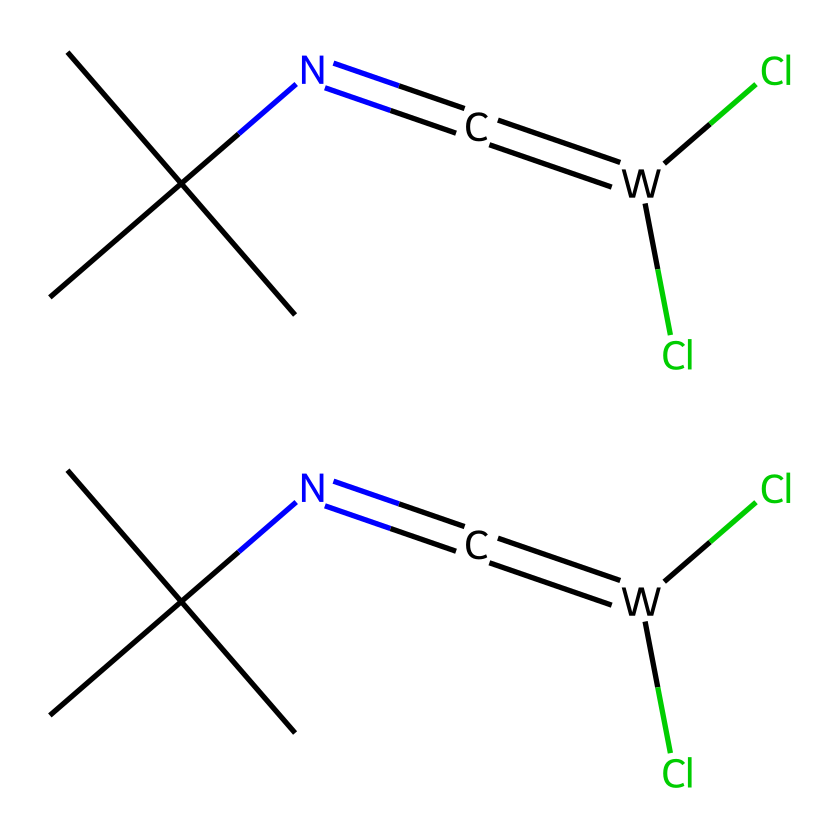What type of chemical is represented by this structure? The structure contains a divalent carbon atom bonded to two other atoms/groups, thus classifying it as a carbene. Carbenes are characterized by the presence of a carbon atom with only six electrons in its valence shell.
Answer: carbene How many chlorine atoms are present in the molecule? By examining the structure, there are two chlorine atoms indicated in the formula, which are part of the overall compound.
Answer: two What is the functional group present in this molecule? The presence of the -N=C= portion in the structure indicates that it is an imine functional group, as it consists of a nitrogen atom double-bonded to a carbon atom that is also double-bonded to another carbon atom.
Answer: imine What is the total number of carbon atoms in the chemical structure? By looking at the SMILES notation, there are six carbon atoms represented within the entire molecule.
Answer: six How many nitrogen atoms are in this chemical? The chemical structure shows there are two nitrogen atoms present, one for each carbene group in the molecule.
Answer: two What type of interactions could this carbene structure facilitate in lubricants? Carbenes can participate in various chemical interactions, notably coordination and π-stacking, which can enhance lubricant properties such as friction reduction and wear resistance in the context of aircraft control systems.
Answer: π-stacking Are these carbene-based lubricants likely to be stable under high temperatures? Carbenes are typically known for their reactivity, particularly due to their unfilled p-orbitals; however, the stability can vary significantly depending on their specific environments and substituents. Stability is contingent on the exact conditions of use and external factors.
Answer: variable 